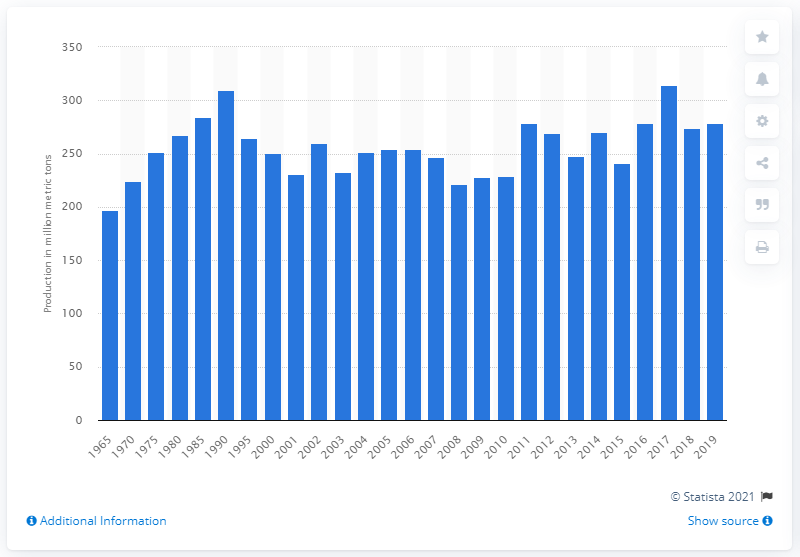Point out several critical features in this image. In the previous year, 273.71 metric tons of sugar beet were produced. In 2019, the global production of sugar beet was estimated to be 278.5 million metric tons. 